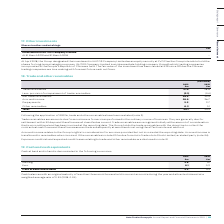From Auto Trader's financial document, What were the currencies in which cash at bank and in hand was denominated in? The document shows two values: Sterling and Euro. From the document: "Sterling 5.8 4.1 Euro 0.1 0.2..." Additionally, In which year was Sterling larger? According to the financial document, 2019. The relevant text states: "At 31 March 2019 and 31 March 2018 –..." Also, can you calculate: What was the change in Cash at bank and in hand in 2019 from 2018? Based on the calculation: 5.9-4.3, the result is 1.6 (in millions). This is based on the information: "Cash at bank and in hand 5.9 4.3 Cash at bank and in hand 5.9 4.3..." The key data points involved are: 4.3, 5.9. Also, can you calculate: What was the percentage change in Cash at bank and in hand in 2019 from 2018? To answer this question, I need to perform calculations using the financial data. The calculation is: (5.9-4.3)/4.3, which equals 37.21 (percentage). This is based on the information: "Cash at bank and in hand 5.9 4.3 Cash at bank and in hand 5.9 4.3..." The key data points involved are: 4.3, 5.9. Also, Where were cash balances with an original maturity of less than three months held in? held in current accounts during the year. The document states: "original maturity of less than three months were held in current accounts during the year and attracted interest at a weighted average rate of 0.3% (2..." Also, What was the amount of interest attracted by cash balances in 2019? weighted average rate of 0.3%. The document states: "counts during the year and attracted interest at a weighted average rate of 0.3% (2018: 0.3%)...." 